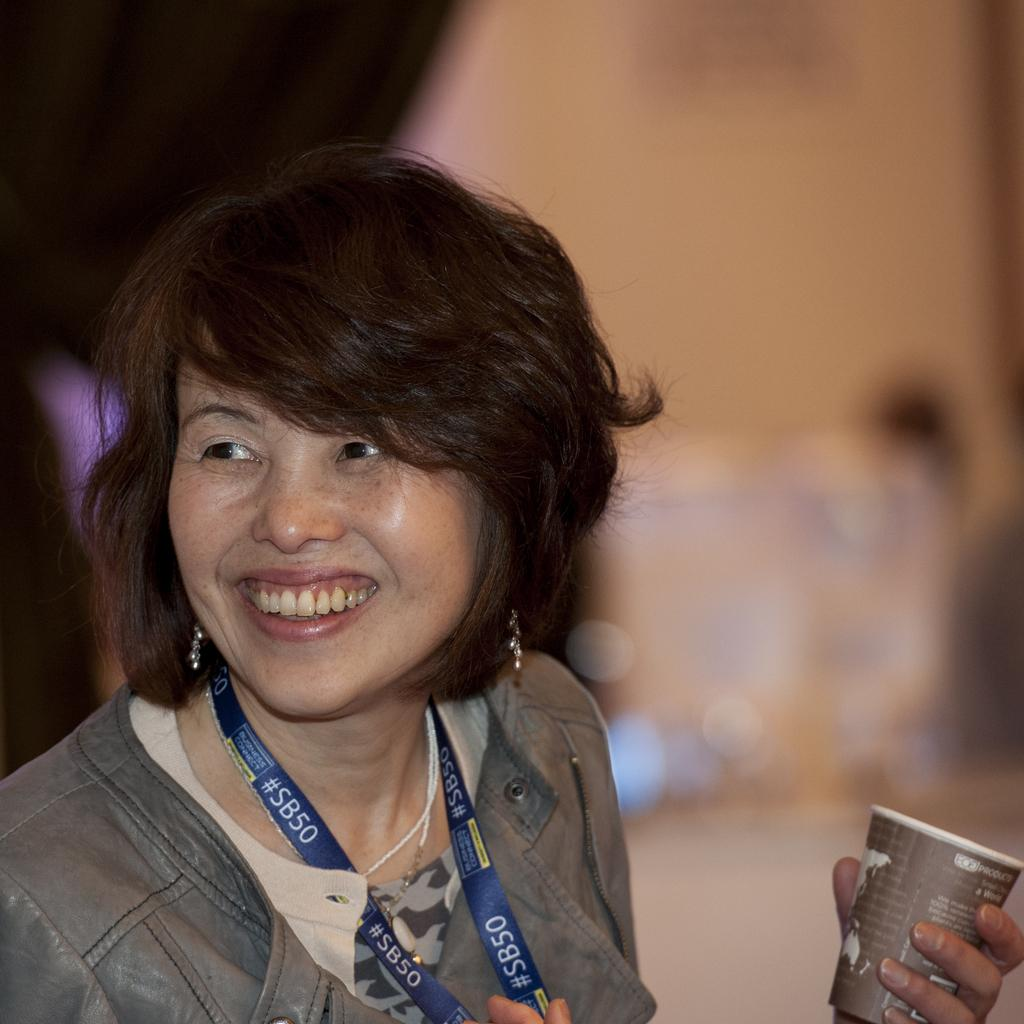Who is present in the image? There is a woman in the image. What is the woman's facial expression? The woman has a smiling face. What is the woman wearing that identifies her? The woman is wearing an ID card tag. What is the woman holding in the image? The woman is holding a cup. What can be seen in the background of the image? There are objects in the background of the image. How is the background of the image depicted? The background is blurred. What type of pie is the woman eating in the image? There is no pie present in the image; the woman is holding a cup. What color is the woman's underwear in the image? There is no information about the woman's underwear in the image, as it is not visible. 